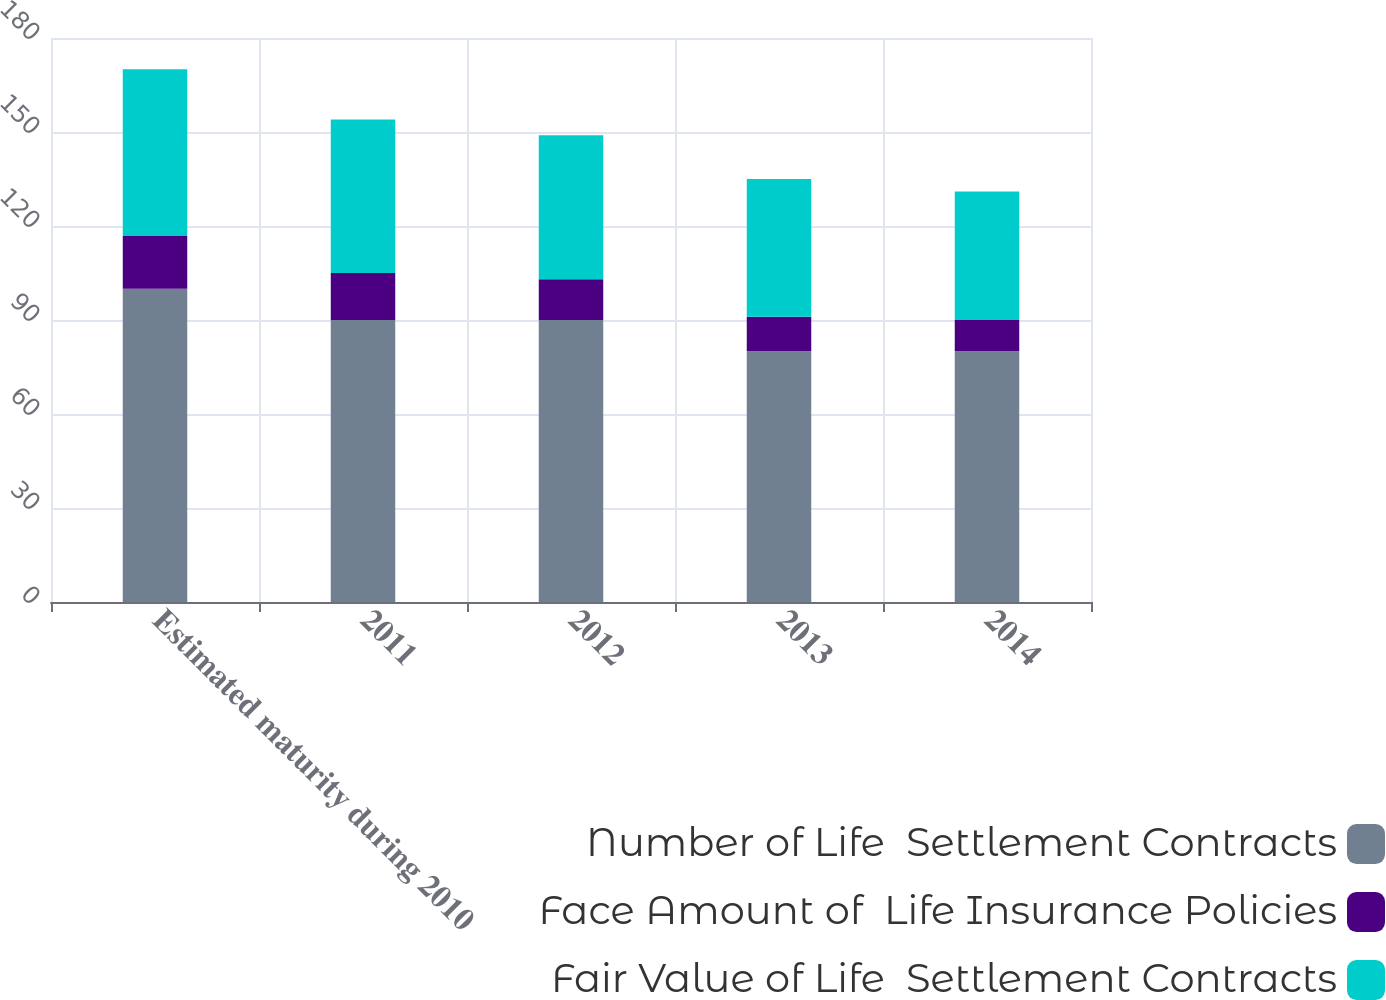Convert chart. <chart><loc_0><loc_0><loc_500><loc_500><stacked_bar_chart><ecel><fcel>Estimated maturity during 2010<fcel>2011<fcel>2012<fcel>2013<fcel>2014<nl><fcel>Number of Life  Settlement Contracts<fcel>100<fcel>90<fcel>90<fcel>80<fcel>80<nl><fcel>Face Amount of  Life Insurance Policies<fcel>17<fcel>15<fcel>13<fcel>11<fcel>10<nl><fcel>Fair Value of Life  Settlement Contracts<fcel>53<fcel>49<fcel>46<fcel>44<fcel>41<nl></chart> 